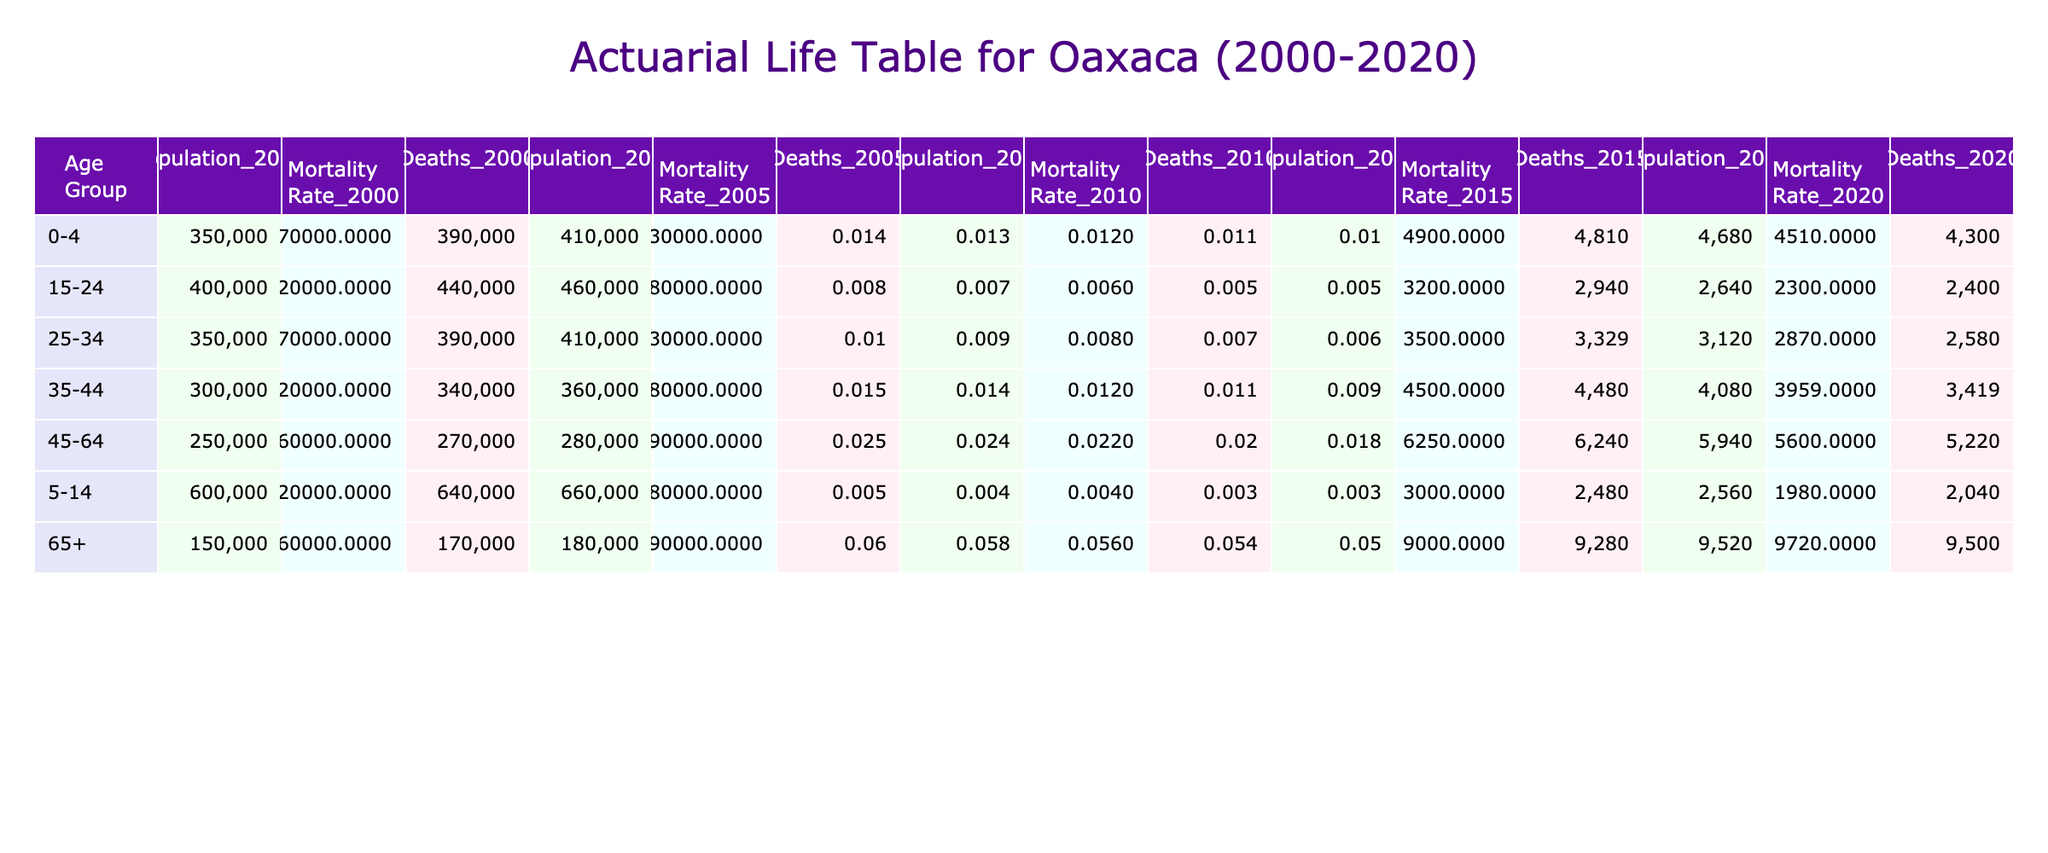What was the mortality rate for the age group 45-64 in the year 2010? According to the table, for the age group 45-64 in the year 2010, the mortality rate is listed as 0.022.
Answer: 0.022 What is the total population of the age group 0-4 in 2020? The table shows that the population for the age group 0-4 in 2020 is 430,000.
Answer: 430000 Is the mortality rate for the age group 5-14 lower in 2020 compared to 2000? In the table, the mortality rate for 5-14 in 2000 is 0.005, and in 2020, it is 0.003. Since 0.003 is lower than 0.005, the statement is true.
Answer: Yes What is the difference in the mortality rate for the age group 65+ between 2000 and 2020? The mortality rate for age group 65+ in 2000 is 0.060, and in 2020 it is 0.050. The difference is calculated by subtracting 0.050 from 0.060, which equals 0.010.
Answer: 0.010 What was the total number of deaths in the age group 25-34 in 2015? To find the total number of deaths, we multiply the population (410,000) by the mortality rate (0.007) for the year 2015. The calculation gives 410000 * 0.007 = 2870 deaths.
Answer: 2870 How does the mortality rate for the 35-44 age group in 2020 compare to that in 2000? The mortality rate for the age group 35-44 in 2000 is 0.015, while in 2020 it is 0.009. Since 0.009 is less than 0.015, the mortality rate has decreased over the years.
Answer: Decreased What was the population in the age group 15-24 over the years from 2000 to 2020? The table shows the following populations for the age group 15-24: 400,000 (2000), 420,000 (2005), 440,000 (2010), 460,000 (2015), and 480,000 (2020). Summing these gives 400000 + 420000 + 440000 + 460000 + 480000 = 2200000.
Answer: 2200000 Is the mortality rate for the age group 45-64 consistently decreasing from 2000 to 2020? By examining the mortality rates in the table for the age group 45-64 (0.025 in 2000, 0.024 in 2005, 0.022 in 2010, 0.020 in 2015, and 0.018 in 2020), we can observe that the rates are decreasing each year. Thus, the answer is yes.
Answer: Yes 